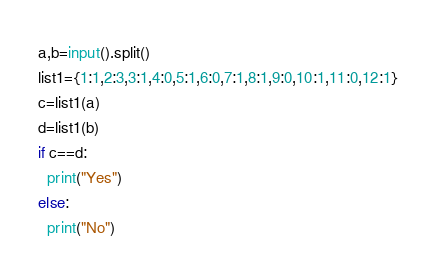Convert code to text. <code><loc_0><loc_0><loc_500><loc_500><_Python_>a,b=input().split()
list1={1:1,2:3,3:1,4:0,5:1,6:0,7:1,8:1,9:0,10:1,11:0,12:1}
c=list1(a)
d=list1(b)
if c==d:
  print("Yes")
else:
  print("No")</code> 